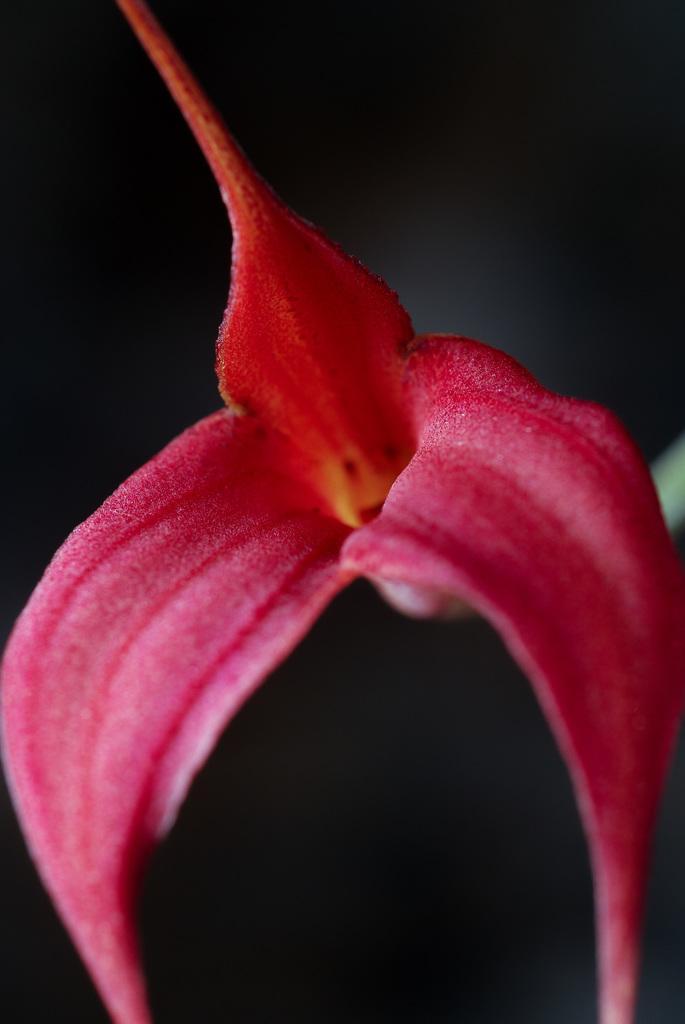Please provide a concise description of this image. In this picture I can see a pink color flower. The background of the image is dark. 